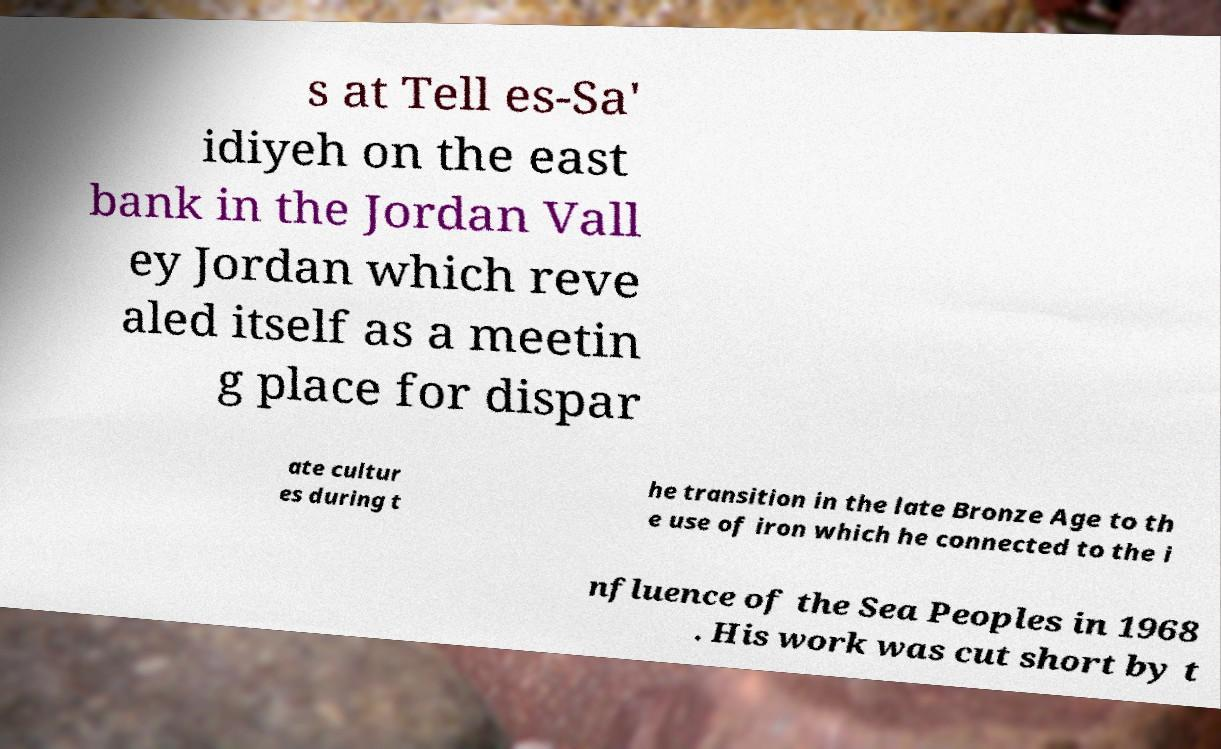Could you extract and type out the text from this image? s at Tell es-Sa' idiyeh on the east bank in the Jordan Vall ey Jordan which reve aled itself as a meetin g place for dispar ate cultur es during t he transition in the late Bronze Age to th e use of iron which he connected to the i nfluence of the Sea Peoples in 1968 . His work was cut short by t 